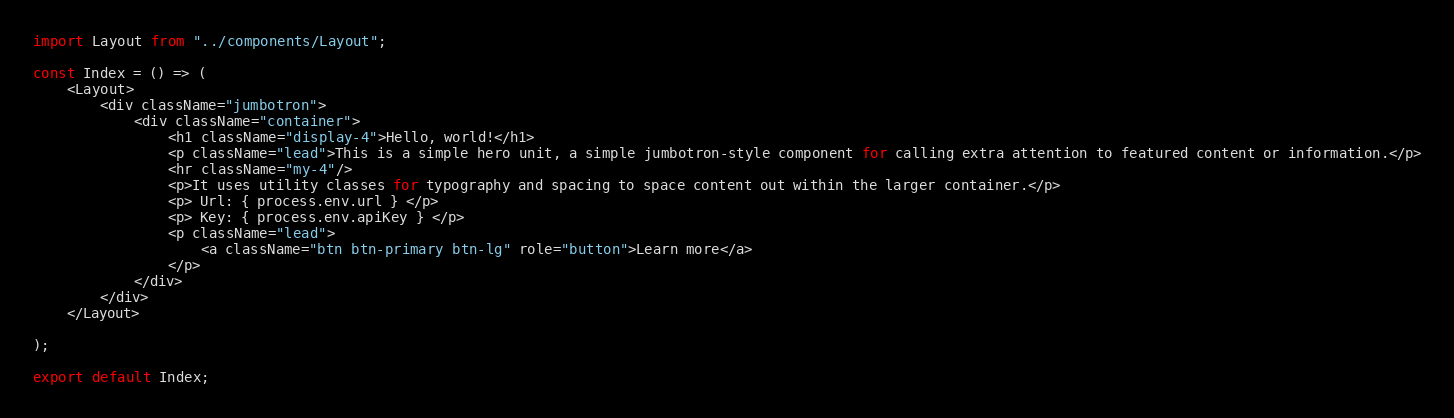Convert code to text. <code><loc_0><loc_0><loc_500><loc_500><_JavaScript_>import Layout from "../components/Layout";

const Index = () => (
    <Layout>
        <div className="jumbotron">
            <div className="container">
                <h1 className="display-4">Hello, world!</h1>
                <p className="lead">This is a simple hero unit, a simple jumbotron-style component for calling extra attention to featured content or information.</p>
                <hr className="my-4"/>
                <p>It uses utility classes for typography and spacing to space content out within the larger container.</p>
                <p> Url: { process.env.url } </p>
                <p> Key: { process.env.apiKey } </p>
                <p className="lead">
                    <a className="btn btn-primary btn-lg" role="button">Learn more</a>
                </p>
            </div>
        </div>
    </Layout>

);

export default Index;</code> 